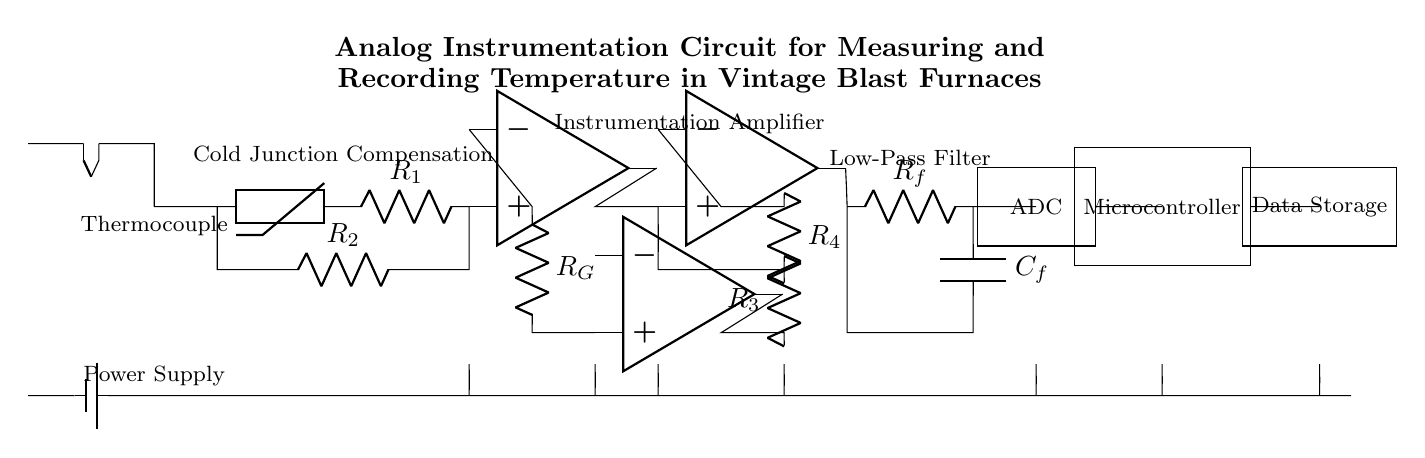What type of sensor is used in this circuit? The circuit uses a thermocouple, as indicated at the beginning of the circuit where the thermocouple component is specifically labeled.
Answer: Thermocouple What does the cold junction compensation use? The circuit indicates that cold junction compensation utilizes a thermistor, which is clearly marked as the component immediately following the thermocouple.
Answer: Thermistor How many operational amplifiers are present in the circuit? By counting the op amp symbols in the circuit diagram, there are three operational amplifiers clearly represented, with their inputs and outputs labeled.
Answer: Three What is the purpose of the low-pass filter in this circuit? The low-pass filter is used to reduce high-frequency noise in the temperature signal before it is processed by the ADC, as it is positioned after the instrumentation amplifier to clean the signal.
Answer: Noise reduction What is the role of the ADC in this circuit? The ADC converts the analog signal from the low-pass filter into a digital signal that the microcontroller can process, enabling data analysis and storage.
Answer: Analog to digital conversion What is the data storage device used in this circuit? The circuit diagram labels the data storage component, indicating it as a rectangular box identified as 'Data Storage', where temperature measurements will be recorded.
Answer: Data Storage What is the function of the power supply in this circuit? The power supply is essential to provide the necessary voltage and current for the operation of all components within the circuit, ensuring functionality of the thermocouple, amplifiers, ADC, and microcontroller.
Answer: Power supply 